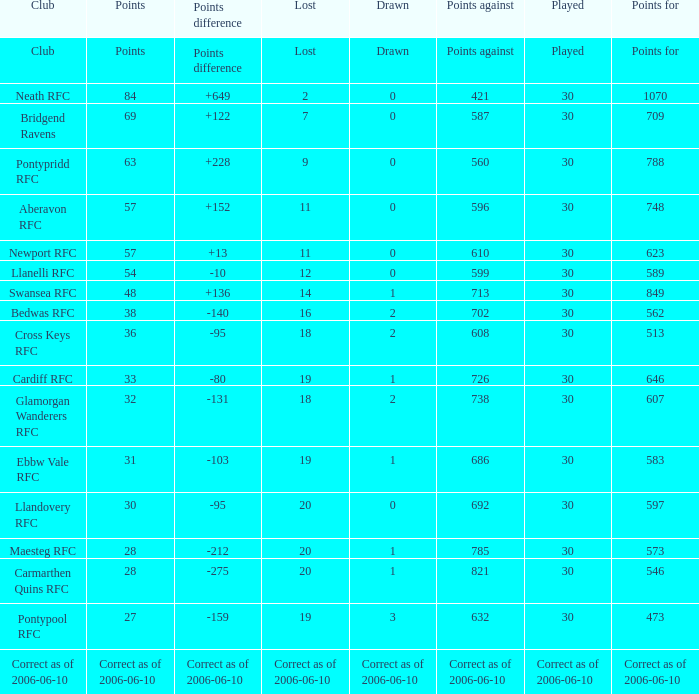What is Points Against, when Drawn is "2", and when Points Of is "32"? 738.0. I'm looking to parse the entire table for insights. Could you assist me with that? {'header': ['Club', 'Points', 'Points difference', 'Lost', 'Drawn', 'Points against', 'Played', 'Points for'], 'rows': [['Club', 'Points', 'Points difference', 'Lost', 'Drawn', 'Points against', 'Played', 'Points for'], ['Neath RFC', '84', '+649', '2', '0', '421', '30', '1070'], ['Bridgend Ravens', '69', '+122', '7', '0', '587', '30', '709'], ['Pontypridd RFC', '63', '+228', '9', '0', '560', '30', '788'], ['Aberavon RFC', '57', '+152', '11', '0', '596', '30', '748'], ['Newport RFC', '57', '+13', '11', '0', '610', '30', '623'], ['Llanelli RFC', '54', '-10', '12', '0', '599', '30', '589'], ['Swansea RFC', '48', '+136', '14', '1', '713', '30', '849'], ['Bedwas RFC', '38', '-140', '16', '2', '702', '30', '562'], ['Cross Keys RFC', '36', '-95', '18', '2', '608', '30', '513'], ['Cardiff RFC', '33', '-80', '19', '1', '726', '30', '646'], ['Glamorgan Wanderers RFC', '32', '-131', '18', '2', '738', '30', '607'], ['Ebbw Vale RFC', '31', '-103', '19', '1', '686', '30', '583'], ['Llandovery RFC', '30', '-95', '20', '0', '692', '30', '597'], ['Maesteg RFC', '28', '-212', '20', '1', '785', '30', '573'], ['Carmarthen Quins RFC', '28', '-275', '20', '1', '821', '30', '546'], ['Pontypool RFC', '27', '-159', '19', '3', '632', '30', '473'], ['Correct as of 2006-06-10', 'Correct as of 2006-06-10', 'Correct as of 2006-06-10', 'Correct as of 2006-06-10', 'Correct as of 2006-06-10', 'Correct as of 2006-06-10', 'Correct as of 2006-06-10', 'Correct as of 2006-06-10']]} 